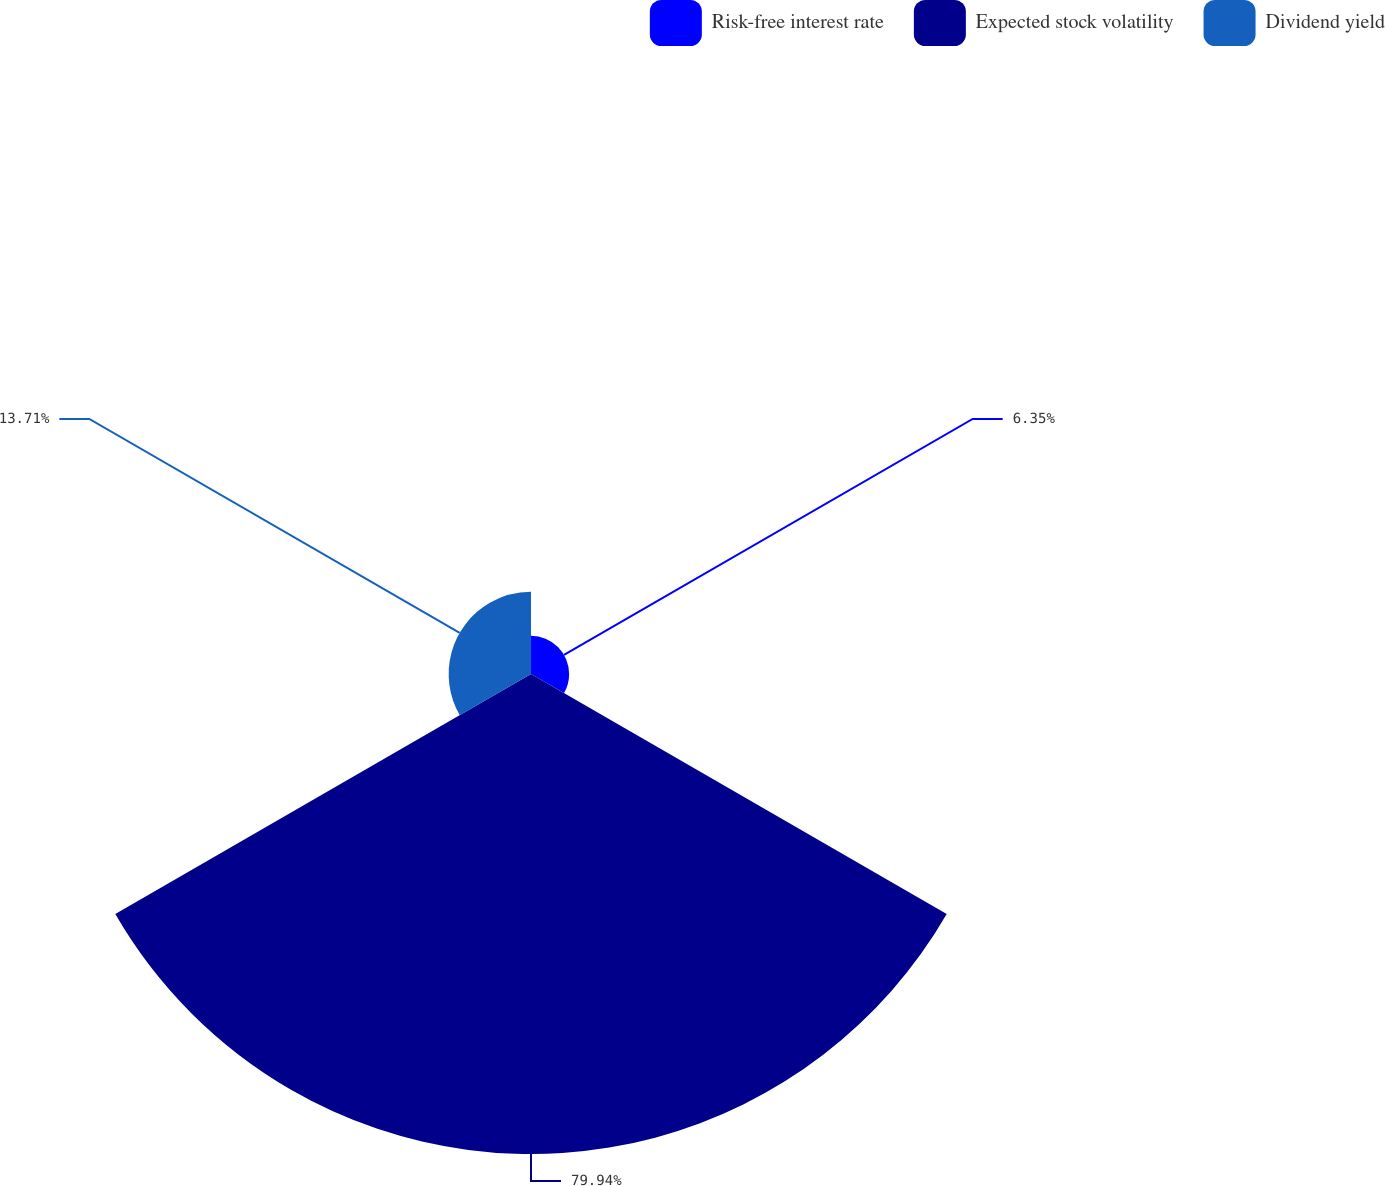<chart> <loc_0><loc_0><loc_500><loc_500><pie_chart><fcel>Risk-free interest rate<fcel>Expected stock volatility<fcel>Dividend yield<nl><fcel>6.35%<fcel>79.94%<fcel>13.71%<nl></chart> 